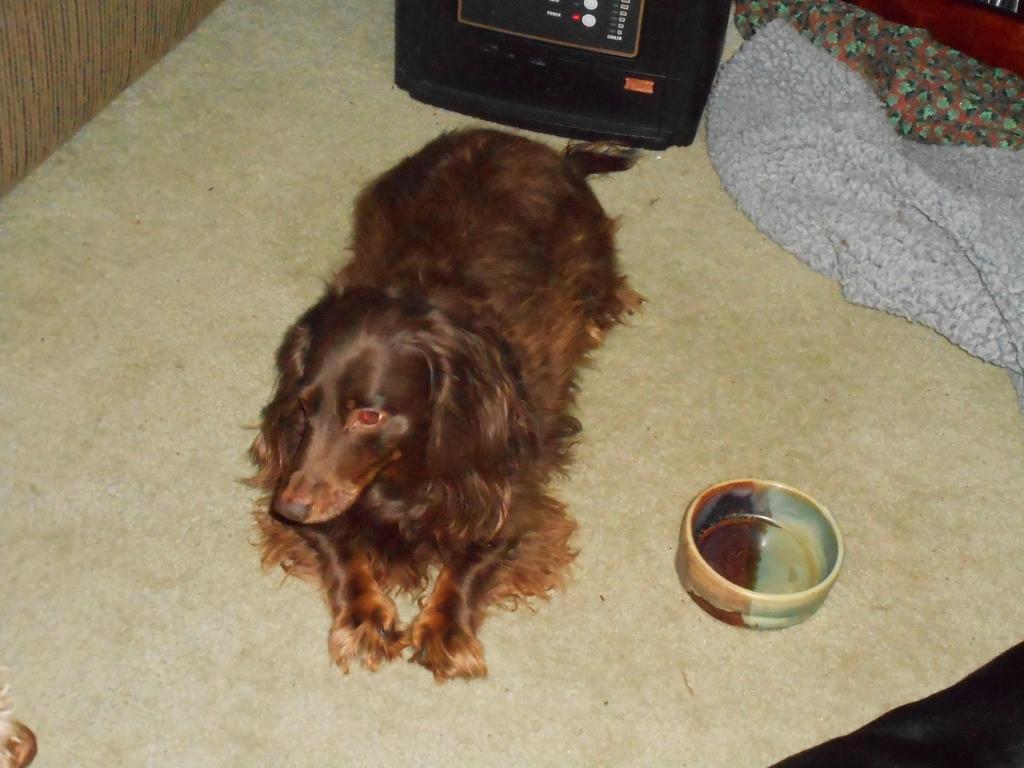Please provide a concise description of this image. In this image at the bottom there is a floor, on the floor there is one dog and beside the dog there is one bowl, and on the right side there are some blankets. On the top of the image there is one television. 